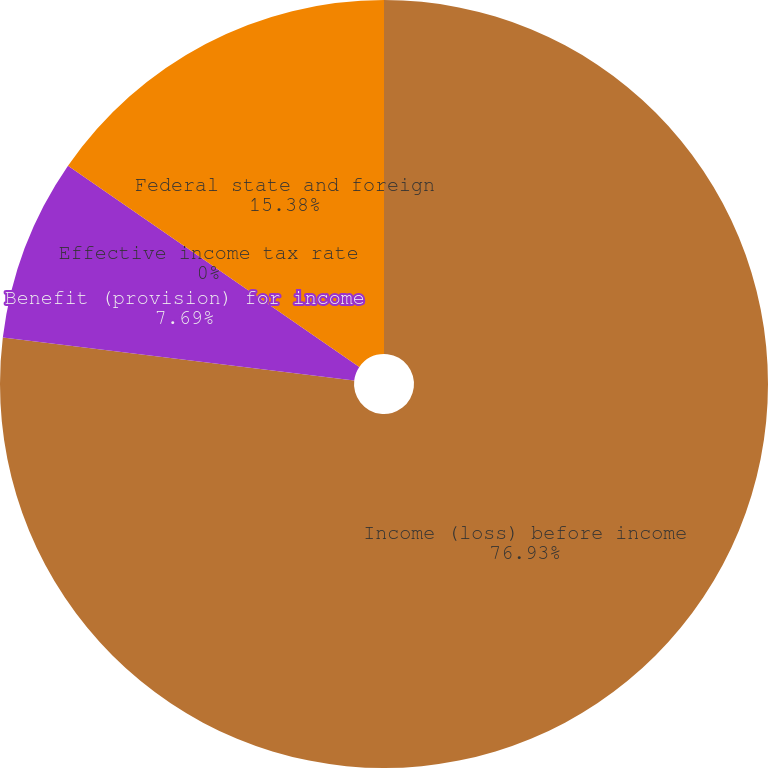<chart> <loc_0><loc_0><loc_500><loc_500><pie_chart><fcel>Income (loss) before income<fcel>Benefit (provision) for income<fcel>Effective income tax rate<fcel>Federal state and foreign<nl><fcel>76.92%<fcel>7.69%<fcel>0.0%<fcel>15.38%<nl></chart> 